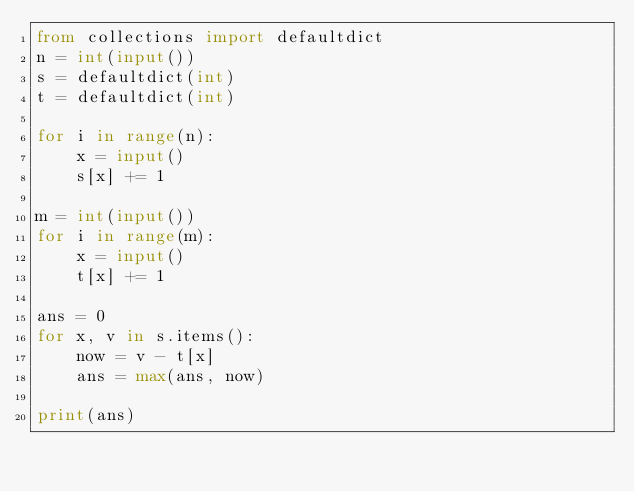<code> <loc_0><loc_0><loc_500><loc_500><_Python_>from collections import defaultdict
n = int(input())
s = defaultdict(int)
t = defaultdict(int)

for i in range(n):
    x = input()
    s[x] += 1

m = int(input())
for i in range(m):
    x = input()
    t[x] += 1

ans = 0
for x, v in s.items():
    now = v - t[x]
    ans = max(ans, now)

print(ans)
</code> 